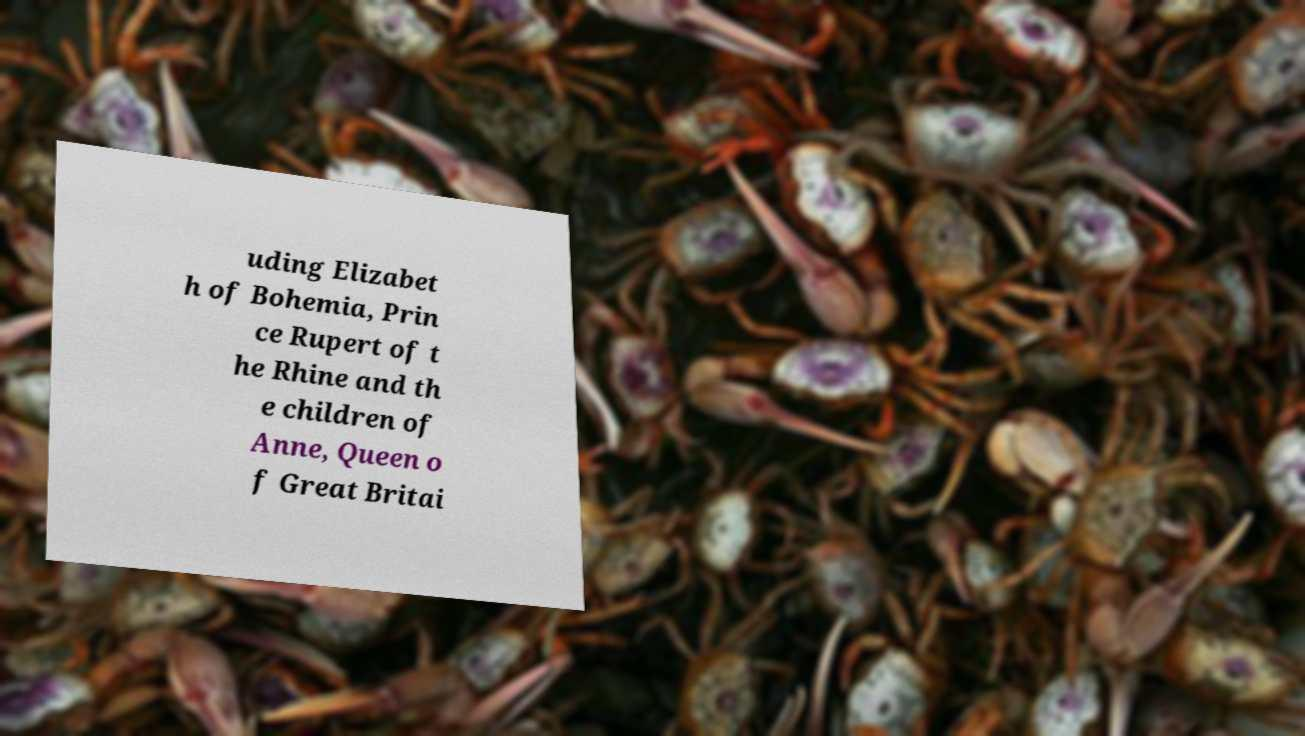Please read and relay the text visible in this image. What does it say? uding Elizabet h of Bohemia, Prin ce Rupert of t he Rhine and th e children of Anne, Queen o f Great Britai 